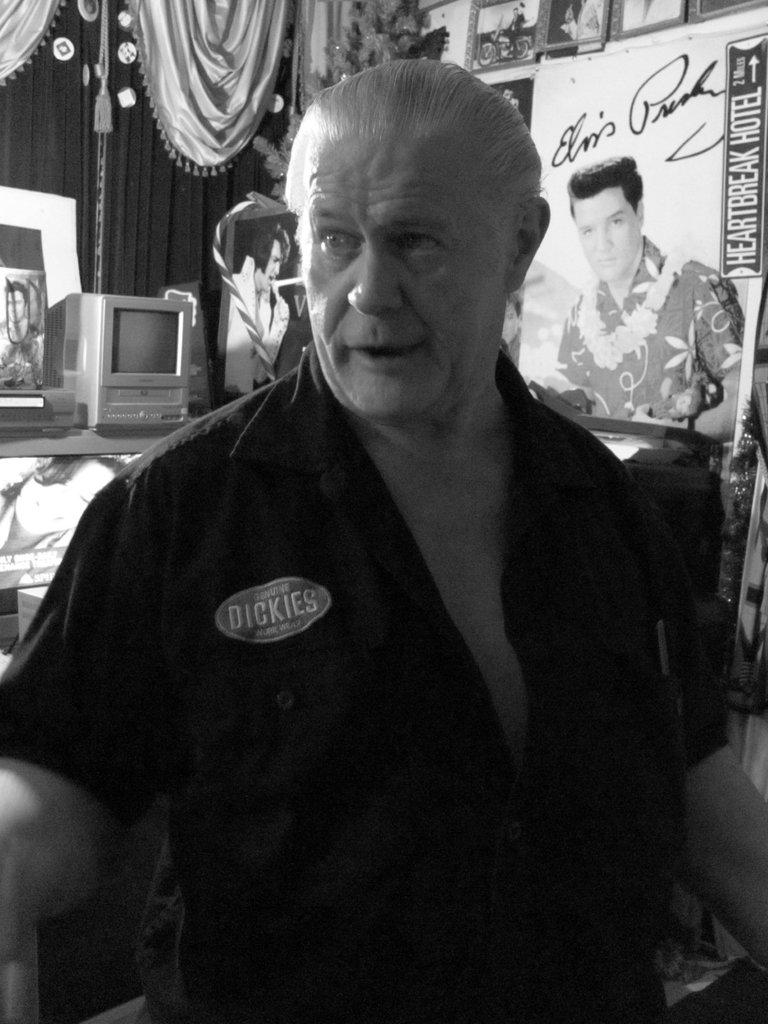Who is present in the image? There is a man in the image. What is the man wearing? The man is wearing a black shirt. What can be seen on the left side of the image? There is a computer on the left side of the image. What type of window treatment is present in the image? There is a curtain in the image. What is visible in the background of the image? There are many frames in the background of the image. What type of cord is being used to hold the frames together in the image? There is no cord visible in the image; the frames are simply hanging in the background. 